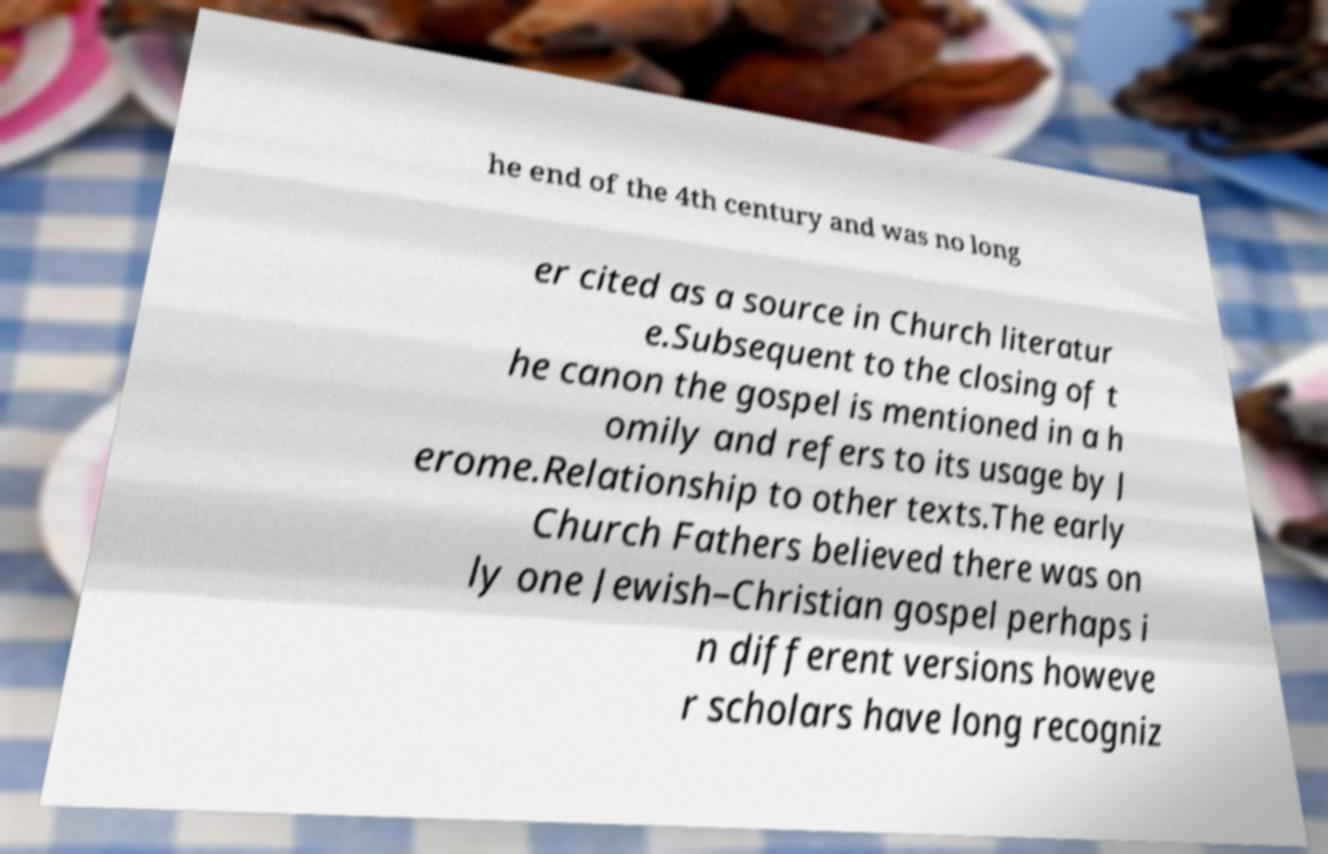There's text embedded in this image that I need extracted. Can you transcribe it verbatim? he end of the 4th century and was no long er cited as a source in Church literatur e.Subsequent to the closing of t he canon the gospel is mentioned in a h omily and refers to its usage by J erome.Relationship to other texts.The early Church Fathers believed there was on ly one Jewish–Christian gospel perhaps i n different versions howeve r scholars have long recogniz 